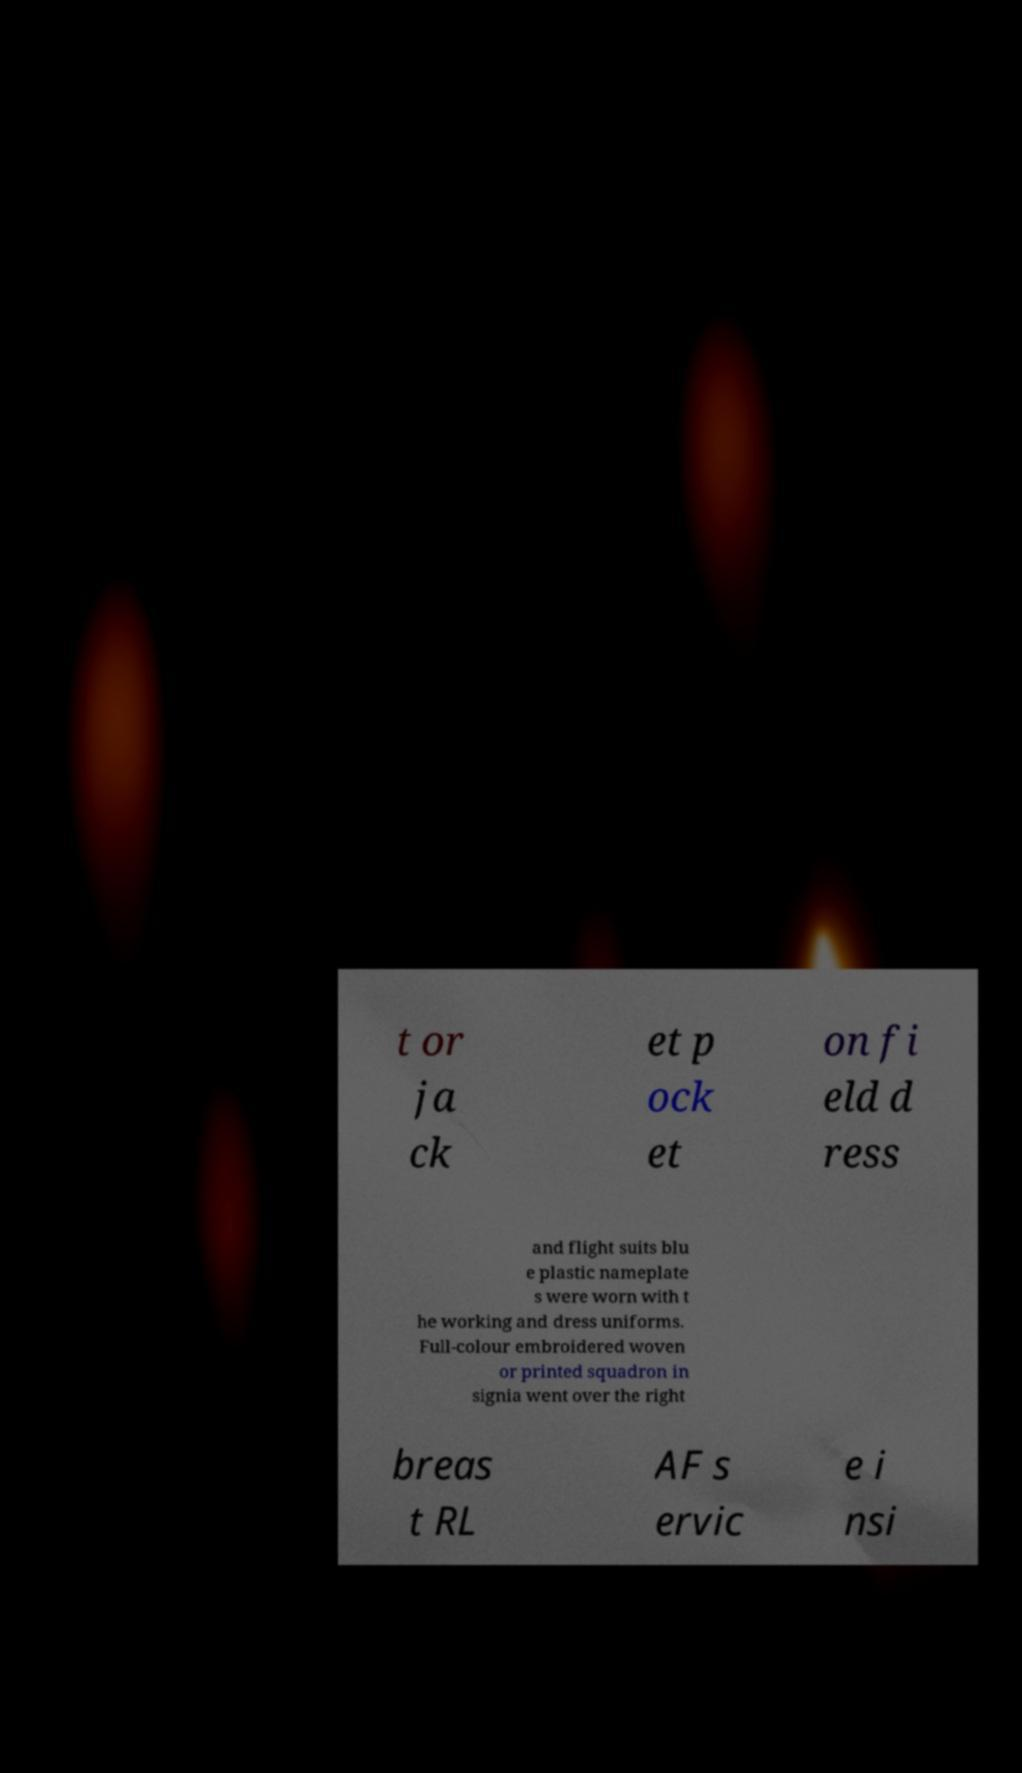For documentation purposes, I need the text within this image transcribed. Could you provide that? t or ja ck et p ock et on fi eld d ress and flight suits blu e plastic nameplate s were worn with t he working and dress uniforms. Full-colour embroidered woven or printed squadron in signia went over the right breas t RL AF s ervic e i nsi 